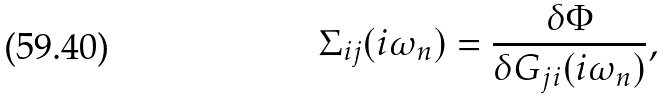<formula> <loc_0><loc_0><loc_500><loc_500>\Sigma _ { i j } ( i \omega _ { n } ) = \frac { \delta \Phi } { \delta G _ { j i } ( i \omega _ { n } ) } ,</formula> 